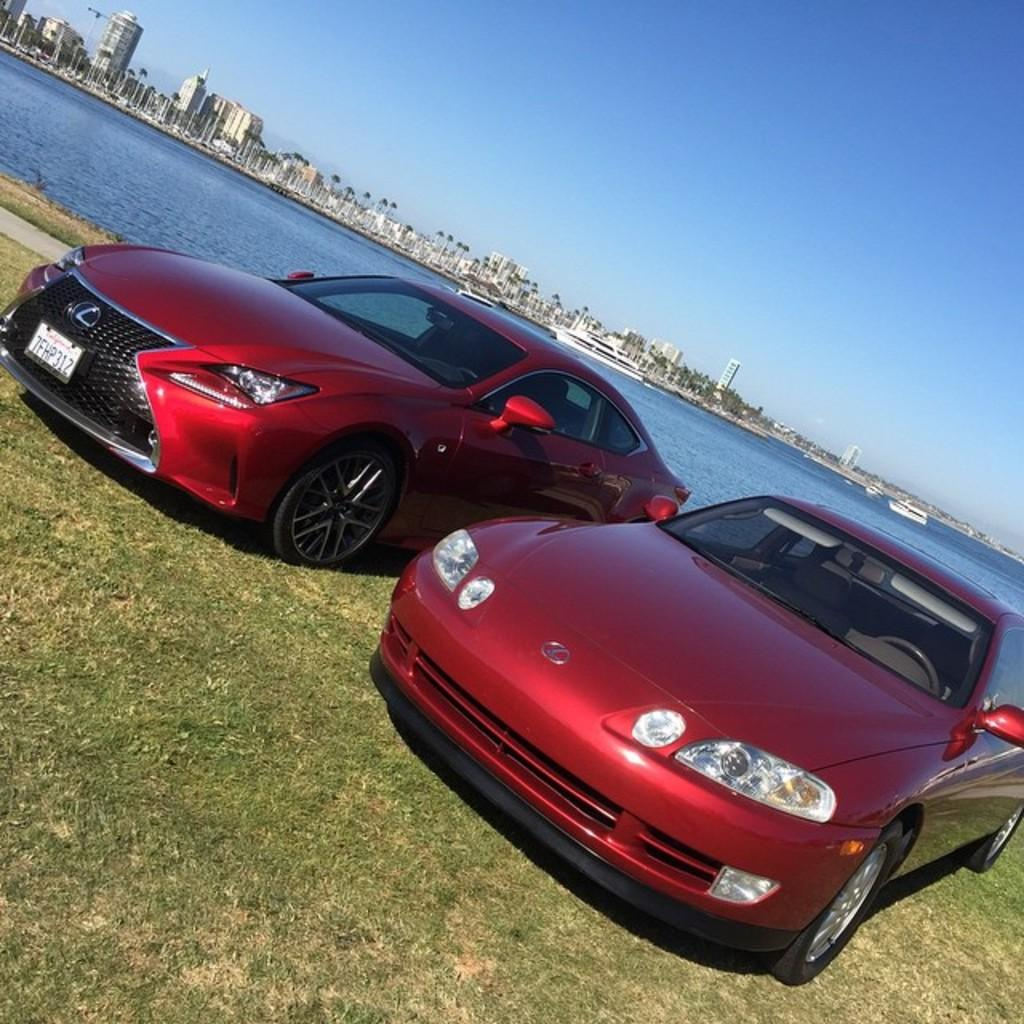What is the main subject of the image? The main subject of the image is cars. What color are the cars? The cars are red. What can be seen in the background of the image? There is a river, buildings, and the sky visible in the background of the image. What type of terrain is at the bottom of the image? There is grass at the bottom of the image. What language is spoken by the creator of the river in the image? There is no information about the creator of the river in the image, nor is there any indication of a language being spoken. 